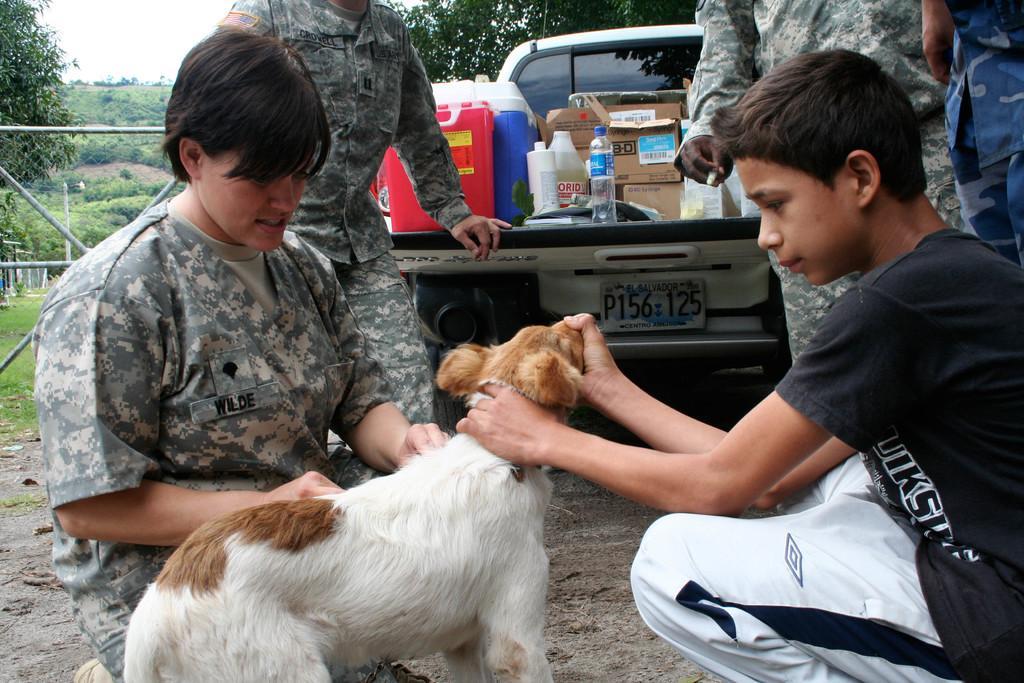In one or two sentences, can you explain what this image depicts? In this picture I can observe a dog in the middle of the picture which is in cream and brown color. I can observe some people on the land. Behind the people I can observe a car. In the background there are trees and sky. 